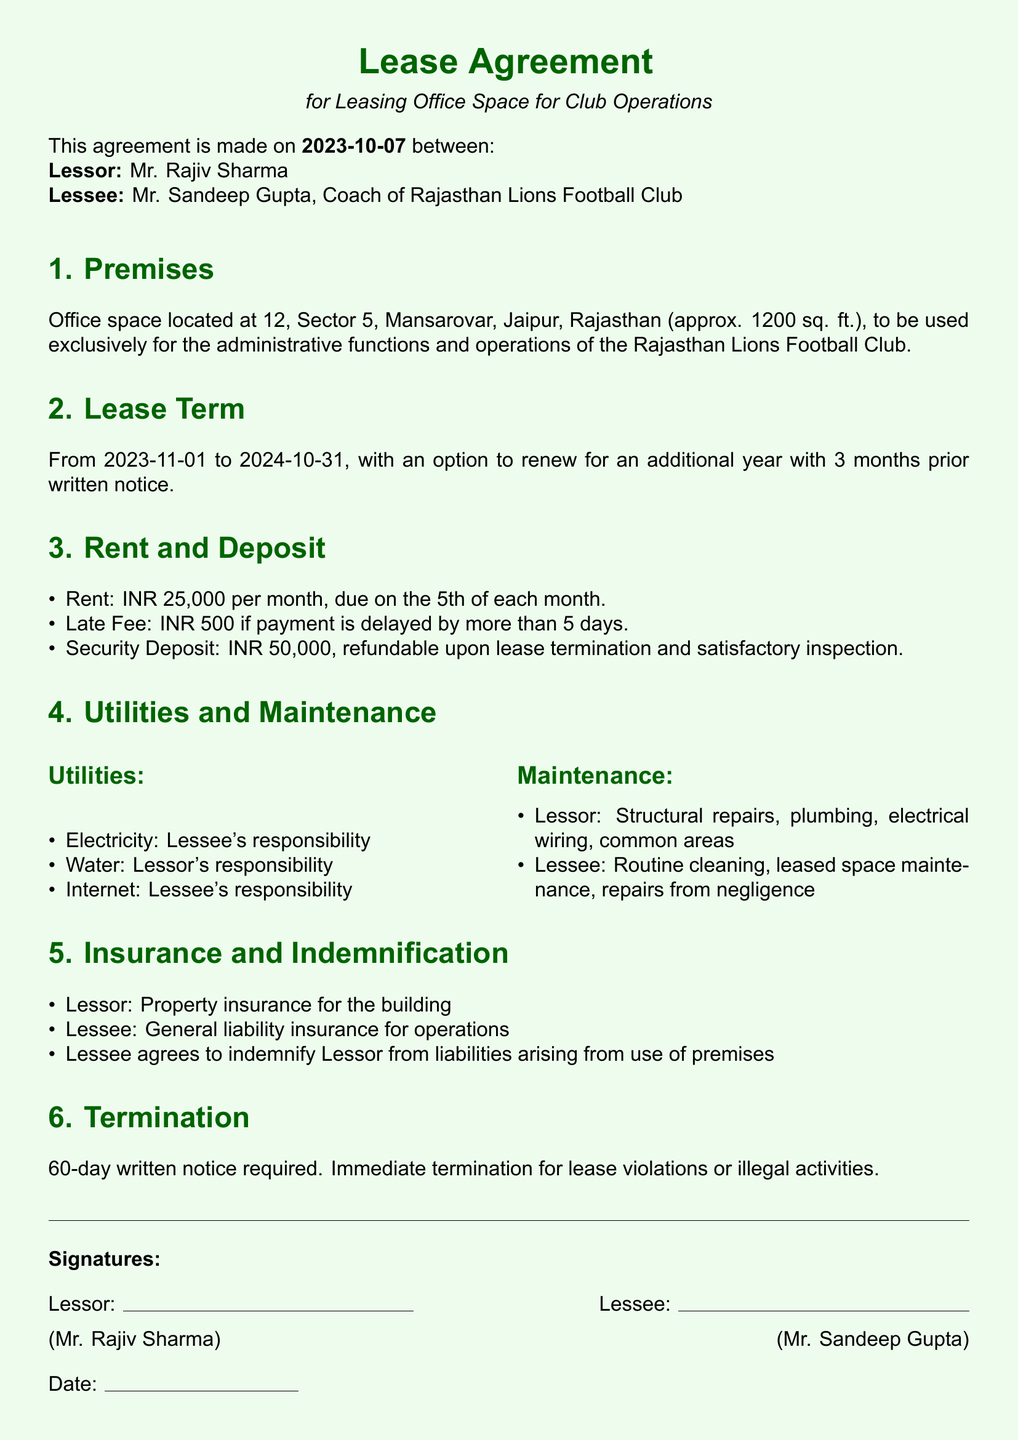What is the start date of the lease? The start date of the lease is explicitly mentioned in the document and is a specific date related to the lease term.
Answer: 2023-11-01 What is the monthly rent amount? The document specifies the amount the lessee has to pay each month as rent, which is clearly stated.
Answer: INR 25,000 Who is responsible for paying the internet bill? Responsibilities for various utilities, including the internet, are outlined in the document, clarifying who bears the financial responsibility.
Answer: Lessee How long is the lease term? The lease term is defined in the document, indicating the duration for which the agreement is valid.
Answer: 1 year What is the late fee for overdue rent? The document outlines the penalties for delayed payments, including late fees for rent, detailing the amount without needing further calculation.
Answer: INR 500 What notice period is required for termination? The document specifies the required notice period for lease termination, which reflects the agreement between lessor and lessee.
Answer: 60 days Who is responsible for structural repairs? Maintenance responsibilities are categorized in the document, distinguishing between the lessor's and lessee's duties for clarity in operations.
Answer: Lessor What is the refundable security deposit amount? The document provides details about the security deposit and its conditions regarding refunds, stating a specific amount that must be returned under certain circumstances.
Answer: INR 50,000 Who signed the lease agreement as the lessee? The individuals involved in the lease agreement, including their titles, are provided in the document, identifying the lessee specifically.
Answer: Mr. Sandeep Gupta 